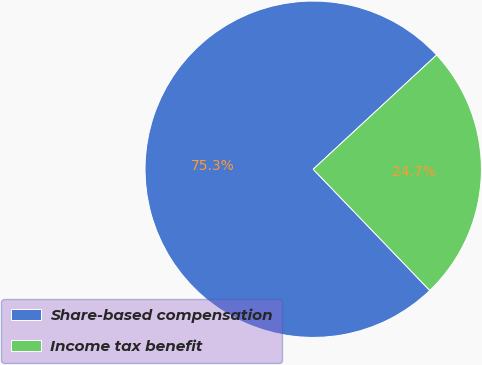Convert chart to OTSL. <chart><loc_0><loc_0><loc_500><loc_500><pie_chart><fcel>Share-based compensation<fcel>Income tax benefit<nl><fcel>75.3%<fcel>24.7%<nl></chart> 